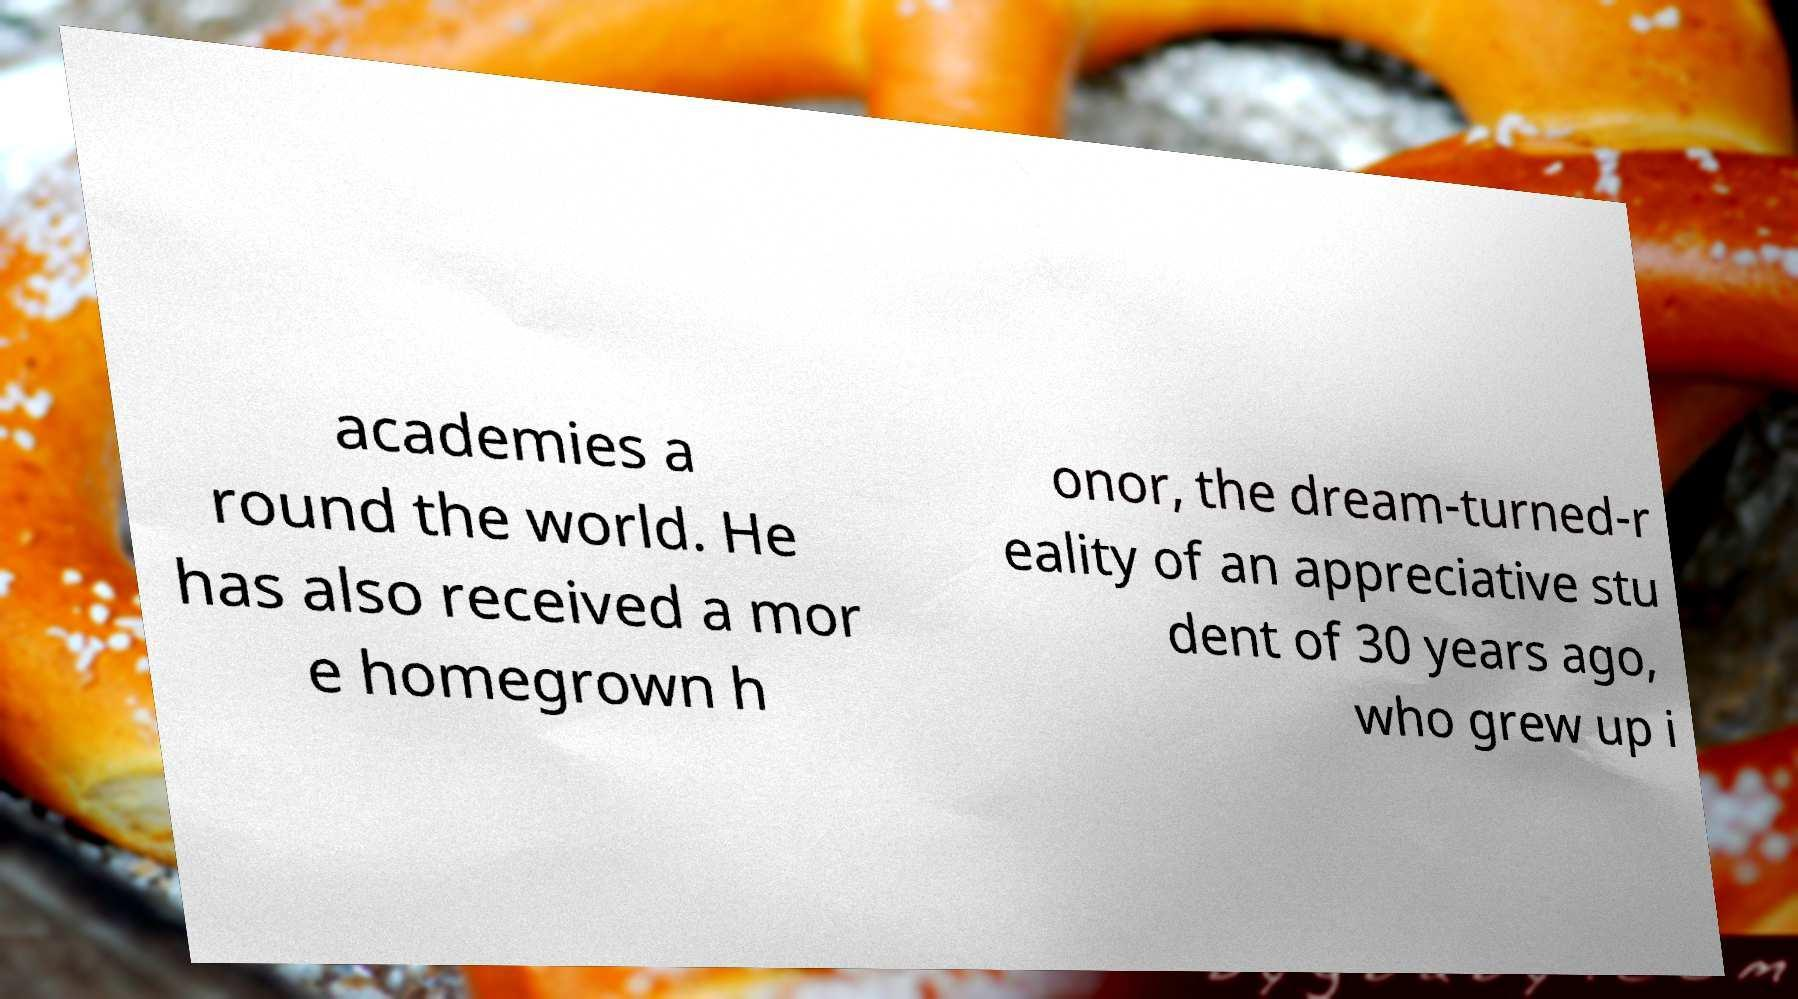What messages or text are displayed in this image? I need them in a readable, typed format. academies a round the world. He has also received a mor e homegrown h onor, the dream-turned-r eality of an appreciative stu dent of 30 years ago, who grew up i 